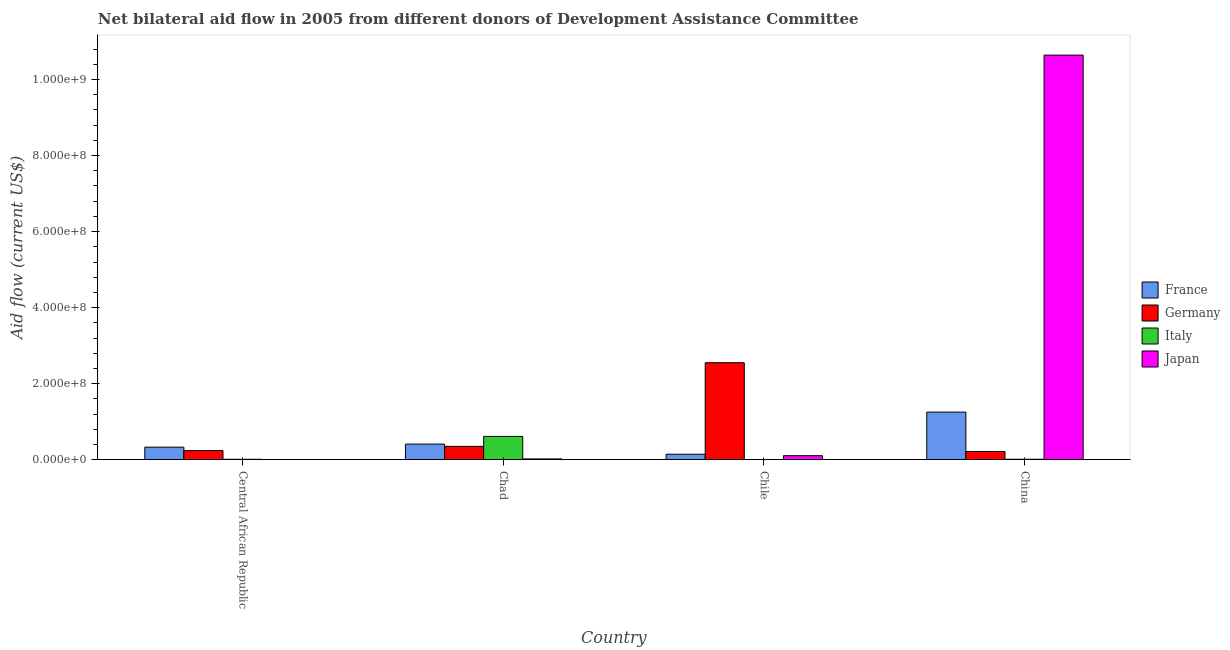How many bars are there on the 4th tick from the left?
Your response must be concise. 4. How many bars are there on the 2nd tick from the right?
Make the answer very short. 3. What is the label of the 1st group of bars from the left?
Offer a very short reply. Central African Republic. In how many cases, is the number of bars for a given country not equal to the number of legend labels?
Your answer should be compact. 1. What is the amount of aid given by italy in Chad?
Provide a short and direct response. 6.12e+07. Across all countries, what is the maximum amount of aid given by germany?
Give a very brief answer. 2.55e+08. In which country was the amount of aid given by italy maximum?
Offer a terse response. Chad. What is the total amount of aid given by italy in the graph?
Keep it short and to the point. 6.34e+07. What is the difference between the amount of aid given by france in Chile and that in China?
Ensure brevity in your answer.  -1.11e+08. What is the difference between the amount of aid given by japan in Chad and the amount of aid given by france in Chile?
Ensure brevity in your answer.  -1.24e+07. What is the average amount of aid given by germany per country?
Provide a short and direct response. 8.39e+07. What is the difference between the amount of aid given by italy and amount of aid given by japan in Chad?
Offer a terse response. 5.92e+07. What is the ratio of the amount of aid given by italy in Central African Republic to that in China?
Ensure brevity in your answer.  0.86. Is the amount of aid given by france in Central African Republic less than that in Chad?
Offer a very short reply. Yes. What is the difference between the highest and the second highest amount of aid given by italy?
Offer a very short reply. 6.01e+07. What is the difference between the highest and the lowest amount of aid given by japan?
Ensure brevity in your answer.  1.06e+09. In how many countries, is the amount of aid given by france greater than the average amount of aid given by france taken over all countries?
Make the answer very short. 1. Does the graph contain grids?
Your response must be concise. No. How many legend labels are there?
Provide a succinct answer. 4. What is the title of the graph?
Provide a succinct answer. Net bilateral aid flow in 2005 from different donors of Development Assistance Committee. What is the label or title of the Y-axis?
Provide a succinct answer. Aid flow (current US$). What is the Aid flow (current US$) of France in Central African Republic?
Provide a short and direct response. 3.30e+07. What is the Aid flow (current US$) of Germany in Central African Republic?
Offer a very short reply. 2.40e+07. What is the Aid flow (current US$) in Italy in Central African Republic?
Provide a short and direct response. 1.02e+06. What is the Aid flow (current US$) of Japan in Central African Republic?
Your answer should be compact. 1.50e+05. What is the Aid flow (current US$) in France in Chad?
Your answer should be very brief. 4.11e+07. What is the Aid flow (current US$) of Germany in Chad?
Provide a succinct answer. 3.52e+07. What is the Aid flow (current US$) of Italy in Chad?
Offer a very short reply. 6.12e+07. What is the Aid flow (current US$) in Japan in Chad?
Provide a succinct answer. 2.05e+06. What is the Aid flow (current US$) of France in Chile?
Make the answer very short. 1.44e+07. What is the Aid flow (current US$) in Germany in Chile?
Ensure brevity in your answer.  2.55e+08. What is the Aid flow (current US$) in Italy in Chile?
Your response must be concise. 0. What is the Aid flow (current US$) in Japan in Chile?
Offer a very short reply. 1.06e+07. What is the Aid flow (current US$) in France in China?
Your answer should be very brief. 1.25e+08. What is the Aid flow (current US$) in Germany in China?
Keep it short and to the point. 2.15e+07. What is the Aid flow (current US$) of Italy in China?
Your answer should be compact. 1.18e+06. What is the Aid flow (current US$) in Japan in China?
Provide a short and direct response. 1.06e+09. Across all countries, what is the maximum Aid flow (current US$) of France?
Your answer should be compact. 1.25e+08. Across all countries, what is the maximum Aid flow (current US$) in Germany?
Ensure brevity in your answer.  2.55e+08. Across all countries, what is the maximum Aid flow (current US$) of Italy?
Give a very brief answer. 6.12e+07. Across all countries, what is the maximum Aid flow (current US$) in Japan?
Provide a short and direct response. 1.06e+09. Across all countries, what is the minimum Aid flow (current US$) in France?
Make the answer very short. 1.44e+07. Across all countries, what is the minimum Aid flow (current US$) in Germany?
Provide a succinct answer. 2.15e+07. What is the total Aid flow (current US$) in France in the graph?
Offer a terse response. 2.14e+08. What is the total Aid flow (current US$) in Germany in the graph?
Ensure brevity in your answer.  3.36e+08. What is the total Aid flow (current US$) of Italy in the graph?
Make the answer very short. 6.34e+07. What is the total Aid flow (current US$) in Japan in the graph?
Provide a short and direct response. 1.08e+09. What is the difference between the Aid flow (current US$) of France in Central African Republic and that in Chad?
Offer a very short reply. -8.08e+06. What is the difference between the Aid flow (current US$) of Germany in Central African Republic and that in Chad?
Your answer should be very brief. -1.12e+07. What is the difference between the Aid flow (current US$) in Italy in Central African Republic and that in Chad?
Your answer should be very brief. -6.02e+07. What is the difference between the Aid flow (current US$) of Japan in Central African Republic and that in Chad?
Your answer should be compact. -1.90e+06. What is the difference between the Aid flow (current US$) in France in Central African Republic and that in Chile?
Your answer should be compact. 1.86e+07. What is the difference between the Aid flow (current US$) in Germany in Central African Republic and that in Chile?
Offer a terse response. -2.31e+08. What is the difference between the Aid flow (current US$) in Japan in Central African Republic and that in Chile?
Your response must be concise. -1.04e+07. What is the difference between the Aid flow (current US$) in France in Central African Republic and that in China?
Offer a terse response. -9.22e+07. What is the difference between the Aid flow (current US$) in Germany in Central African Republic and that in China?
Ensure brevity in your answer.  2.44e+06. What is the difference between the Aid flow (current US$) of Italy in Central African Republic and that in China?
Give a very brief answer. -1.60e+05. What is the difference between the Aid flow (current US$) of Japan in Central African Republic and that in China?
Offer a very short reply. -1.06e+09. What is the difference between the Aid flow (current US$) of France in Chad and that in Chile?
Keep it short and to the point. 2.67e+07. What is the difference between the Aid flow (current US$) of Germany in Chad and that in Chile?
Keep it short and to the point. -2.20e+08. What is the difference between the Aid flow (current US$) in Japan in Chad and that in Chile?
Ensure brevity in your answer.  -8.52e+06. What is the difference between the Aid flow (current US$) in France in Chad and that in China?
Your answer should be very brief. -8.41e+07. What is the difference between the Aid flow (current US$) of Germany in Chad and that in China?
Make the answer very short. 1.36e+07. What is the difference between the Aid flow (current US$) in Italy in Chad and that in China?
Your answer should be very brief. 6.01e+07. What is the difference between the Aid flow (current US$) of Japan in Chad and that in China?
Provide a succinct answer. -1.06e+09. What is the difference between the Aid flow (current US$) in France in Chile and that in China?
Offer a very short reply. -1.11e+08. What is the difference between the Aid flow (current US$) of Germany in Chile and that in China?
Your response must be concise. 2.34e+08. What is the difference between the Aid flow (current US$) of Japan in Chile and that in China?
Make the answer very short. -1.05e+09. What is the difference between the Aid flow (current US$) in France in Central African Republic and the Aid flow (current US$) in Germany in Chad?
Your answer should be very brief. -2.16e+06. What is the difference between the Aid flow (current US$) in France in Central African Republic and the Aid flow (current US$) in Italy in Chad?
Ensure brevity in your answer.  -2.82e+07. What is the difference between the Aid flow (current US$) in France in Central African Republic and the Aid flow (current US$) in Japan in Chad?
Give a very brief answer. 3.09e+07. What is the difference between the Aid flow (current US$) in Germany in Central African Republic and the Aid flow (current US$) in Italy in Chad?
Keep it short and to the point. -3.73e+07. What is the difference between the Aid flow (current US$) in Germany in Central African Republic and the Aid flow (current US$) in Japan in Chad?
Give a very brief answer. 2.19e+07. What is the difference between the Aid flow (current US$) of Italy in Central African Republic and the Aid flow (current US$) of Japan in Chad?
Make the answer very short. -1.03e+06. What is the difference between the Aid flow (current US$) of France in Central African Republic and the Aid flow (current US$) of Germany in Chile?
Offer a terse response. -2.22e+08. What is the difference between the Aid flow (current US$) of France in Central African Republic and the Aid flow (current US$) of Japan in Chile?
Your answer should be very brief. 2.24e+07. What is the difference between the Aid flow (current US$) in Germany in Central African Republic and the Aid flow (current US$) in Japan in Chile?
Ensure brevity in your answer.  1.34e+07. What is the difference between the Aid flow (current US$) of Italy in Central African Republic and the Aid flow (current US$) of Japan in Chile?
Give a very brief answer. -9.55e+06. What is the difference between the Aid flow (current US$) in France in Central African Republic and the Aid flow (current US$) in Germany in China?
Provide a succinct answer. 1.15e+07. What is the difference between the Aid flow (current US$) of France in Central African Republic and the Aid flow (current US$) of Italy in China?
Make the answer very short. 3.18e+07. What is the difference between the Aid flow (current US$) of France in Central African Republic and the Aid flow (current US$) of Japan in China?
Your answer should be compact. -1.03e+09. What is the difference between the Aid flow (current US$) in Germany in Central African Republic and the Aid flow (current US$) in Italy in China?
Provide a short and direct response. 2.28e+07. What is the difference between the Aid flow (current US$) of Germany in Central African Republic and the Aid flow (current US$) of Japan in China?
Your answer should be very brief. -1.04e+09. What is the difference between the Aid flow (current US$) of Italy in Central African Republic and the Aid flow (current US$) of Japan in China?
Provide a short and direct response. -1.06e+09. What is the difference between the Aid flow (current US$) in France in Chad and the Aid flow (current US$) in Germany in Chile?
Offer a very short reply. -2.14e+08. What is the difference between the Aid flow (current US$) in France in Chad and the Aid flow (current US$) in Japan in Chile?
Your answer should be very brief. 3.05e+07. What is the difference between the Aid flow (current US$) in Germany in Chad and the Aid flow (current US$) in Japan in Chile?
Offer a very short reply. 2.46e+07. What is the difference between the Aid flow (current US$) in Italy in Chad and the Aid flow (current US$) in Japan in Chile?
Give a very brief answer. 5.07e+07. What is the difference between the Aid flow (current US$) of France in Chad and the Aid flow (current US$) of Germany in China?
Keep it short and to the point. 1.96e+07. What is the difference between the Aid flow (current US$) in France in Chad and the Aid flow (current US$) in Italy in China?
Your answer should be compact. 3.99e+07. What is the difference between the Aid flow (current US$) of France in Chad and the Aid flow (current US$) of Japan in China?
Provide a succinct answer. -1.02e+09. What is the difference between the Aid flow (current US$) of Germany in Chad and the Aid flow (current US$) of Italy in China?
Offer a very short reply. 3.40e+07. What is the difference between the Aid flow (current US$) in Germany in Chad and the Aid flow (current US$) in Japan in China?
Provide a succinct answer. -1.03e+09. What is the difference between the Aid flow (current US$) in Italy in Chad and the Aid flow (current US$) in Japan in China?
Provide a short and direct response. -1.00e+09. What is the difference between the Aid flow (current US$) in France in Chile and the Aid flow (current US$) in Germany in China?
Offer a very short reply. -7.11e+06. What is the difference between the Aid flow (current US$) in France in Chile and the Aid flow (current US$) in Italy in China?
Keep it short and to the point. 1.32e+07. What is the difference between the Aid flow (current US$) of France in Chile and the Aid flow (current US$) of Japan in China?
Ensure brevity in your answer.  -1.05e+09. What is the difference between the Aid flow (current US$) in Germany in Chile and the Aid flow (current US$) in Italy in China?
Your response must be concise. 2.54e+08. What is the difference between the Aid flow (current US$) in Germany in Chile and the Aid flow (current US$) in Japan in China?
Provide a succinct answer. -8.09e+08. What is the average Aid flow (current US$) in France per country?
Make the answer very short. 5.34e+07. What is the average Aid flow (current US$) in Germany per country?
Your answer should be compact. 8.39e+07. What is the average Aid flow (current US$) in Italy per country?
Provide a short and direct response. 1.59e+07. What is the average Aid flow (current US$) in Japan per country?
Your response must be concise. 2.69e+08. What is the difference between the Aid flow (current US$) in France and Aid flow (current US$) in Germany in Central African Republic?
Ensure brevity in your answer.  9.04e+06. What is the difference between the Aid flow (current US$) of France and Aid flow (current US$) of Italy in Central African Republic?
Provide a short and direct response. 3.20e+07. What is the difference between the Aid flow (current US$) of France and Aid flow (current US$) of Japan in Central African Republic?
Keep it short and to the point. 3.28e+07. What is the difference between the Aid flow (current US$) in Germany and Aid flow (current US$) in Italy in Central African Republic?
Offer a terse response. 2.29e+07. What is the difference between the Aid flow (current US$) of Germany and Aid flow (current US$) of Japan in Central African Republic?
Your answer should be compact. 2.38e+07. What is the difference between the Aid flow (current US$) of Italy and Aid flow (current US$) of Japan in Central African Republic?
Ensure brevity in your answer.  8.70e+05. What is the difference between the Aid flow (current US$) of France and Aid flow (current US$) of Germany in Chad?
Your response must be concise. 5.92e+06. What is the difference between the Aid flow (current US$) of France and Aid flow (current US$) of Italy in Chad?
Ensure brevity in your answer.  -2.02e+07. What is the difference between the Aid flow (current US$) of France and Aid flow (current US$) of Japan in Chad?
Provide a succinct answer. 3.90e+07. What is the difference between the Aid flow (current US$) of Germany and Aid flow (current US$) of Italy in Chad?
Your answer should be very brief. -2.61e+07. What is the difference between the Aid flow (current US$) in Germany and Aid flow (current US$) in Japan in Chad?
Your response must be concise. 3.31e+07. What is the difference between the Aid flow (current US$) in Italy and Aid flow (current US$) in Japan in Chad?
Your answer should be compact. 5.92e+07. What is the difference between the Aid flow (current US$) in France and Aid flow (current US$) in Germany in Chile?
Keep it short and to the point. -2.41e+08. What is the difference between the Aid flow (current US$) of France and Aid flow (current US$) of Japan in Chile?
Ensure brevity in your answer.  3.83e+06. What is the difference between the Aid flow (current US$) in Germany and Aid flow (current US$) in Japan in Chile?
Your answer should be compact. 2.45e+08. What is the difference between the Aid flow (current US$) in France and Aid flow (current US$) in Germany in China?
Give a very brief answer. 1.04e+08. What is the difference between the Aid flow (current US$) of France and Aid flow (current US$) of Italy in China?
Your response must be concise. 1.24e+08. What is the difference between the Aid flow (current US$) of France and Aid flow (current US$) of Japan in China?
Your answer should be very brief. -9.39e+08. What is the difference between the Aid flow (current US$) in Germany and Aid flow (current US$) in Italy in China?
Ensure brevity in your answer.  2.03e+07. What is the difference between the Aid flow (current US$) in Germany and Aid flow (current US$) in Japan in China?
Offer a terse response. -1.04e+09. What is the difference between the Aid flow (current US$) in Italy and Aid flow (current US$) in Japan in China?
Your answer should be very brief. -1.06e+09. What is the ratio of the Aid flow (current US$) of France in Central African Republic to that in Chad?
Make the answer very short. 0.8. What is the ratio of the Aid flow (current US$) in Germany in Central African Republic to that in Chad?
Make the answer very short. 0.68. What is the ratio of the Aid flow (current US$) of Italy in Central African Republic to that in Chad?
Give a very brief answer. 0.02. What is the ratio of the Aid flow (current US$) of Japan in Central African Republic to that in Chad?
Provide a short and direct response. 0.07. What is the ratio of the Aid flow (current US$) in France in Central African Republic to that in Chile?
Provide a short and direct response. 2.29. What is the ratio of the Aid flow (current US$) in Germany in Central African Republic to that in Chile?
Make the answer very short. 0.09. What is the ratio of the Aid flow (current US$) in Japan in Central African Republic to that in Chile?
Make the answer very short. 0.01. What is the ratio of the Aid flow (current US$) of France in Central African Republic to that in China?
Your answer should be very brief. 0.26. What is the ratio of the Aid flow (current US$) of Germany in Central African Republic to that in China?
Ensure brevity in your answer.  1.11. What is the ratio of the Aid flow (current US$) of Italy in Central African Republic to that in China?
Keep it short and to the point. 0.86. What is the ratio of the Aid flow (current US$) in France in Chad to that in Chile?
Ensure brevity in your answer.  2.85. What is the ratio of the Aid flow (current US$) in Germany in Chad to that in Chile?
Give a very brief answer. 0.14. What is the ratio of the Aid flow (current US$) of Japan in Chad to that in Chile?
Keep it short and to the point. 0.19. What is the ratio of the Aid flow (current US$) of France in Chad to that in China?
Provide a succinct answer. 0.33. What is the ratio of the Aid flow (current US$) in Germany in Chad to that in China?
Your response must be concise. 1.63. What is the ratio of the Aid flow (current US$) in Italy in Chad to that in China?
Offer a very short reply. 51.9. What is the ratio of the Aid flow (current US$) in Japan in Chad to that in China?
Ensure brevity in your answer.  0. What is the ratio of the Aid flow (current US$) in France in Chile to that in China?
Ensure brevity in your answer.  0.12. What is the ratio of the Aid flow (current US$) in Germany in Chile to that in China?
Offer a terse response. 11.86. What is the ratio of the Aid flow (current US$) in Japan in Chile to that in China?
Keep it short and to the point. 0.01. What is the difference between the highest and the second highest Aid flow (current US$) in France?
Your answer should be compact. 8.41e+07. What is the difference between the highest and the second highest Aid flow (current US$) in Germany?
Ensure brevity in your answer.  2.20e+08. What is the difference between the highest and the second highest Aid flow (current US$) in Italy?
Make the answer very short. 6.01e+07. What is the difference between the highest and the second highest Aid flow (current US$) of Japan?
Your answer should be very brief. 1.05e+09. What is the difference between the highest and the lowest Aid flow (current US$) of France?
Provide a succinct answer. 1.11e+08. What is the difference between the highest and the lowest Aid flow (current US$) of Germany?
Your answer should be compact. 2.34e+08. What is the difference between the highest and the lowest Aid flow (current US$) of Italy?
Keep it short and to the point. 6.12e+07. What is the difference between the highest and the lowest Aid flow (current US$) of Japan?
Give a very brief answer. 1.06e+09. 